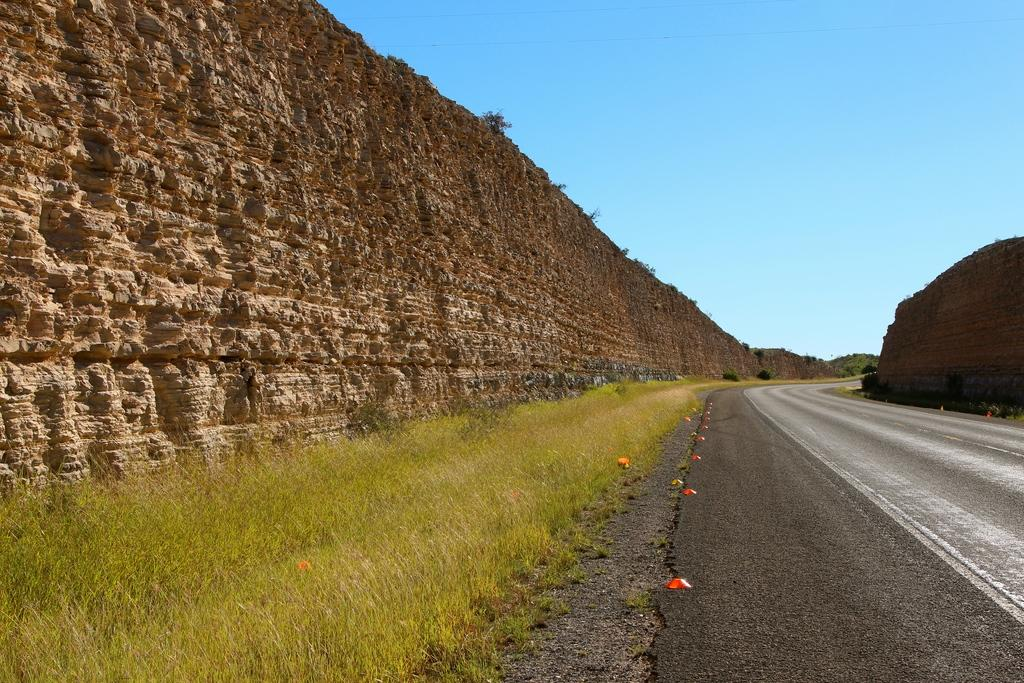What type of structure can be seen in the image? There is a wall in the image. What type of vegetation is present in the image? There are plants and grass in the image. What is at the bottom of the image? There is a road at the bottom of the image. What color are the objects on the road? The objects on the road are red. What can be seen in the background of the image? The sky is visible in the background of the image. What are the hobbies of the creature in the image? There is no creature present in the image, so we cannot determine its hobbies. What is the price of the plants in the image? The price of the plants is not mentioned in the image, so we cannot determine their cost. 